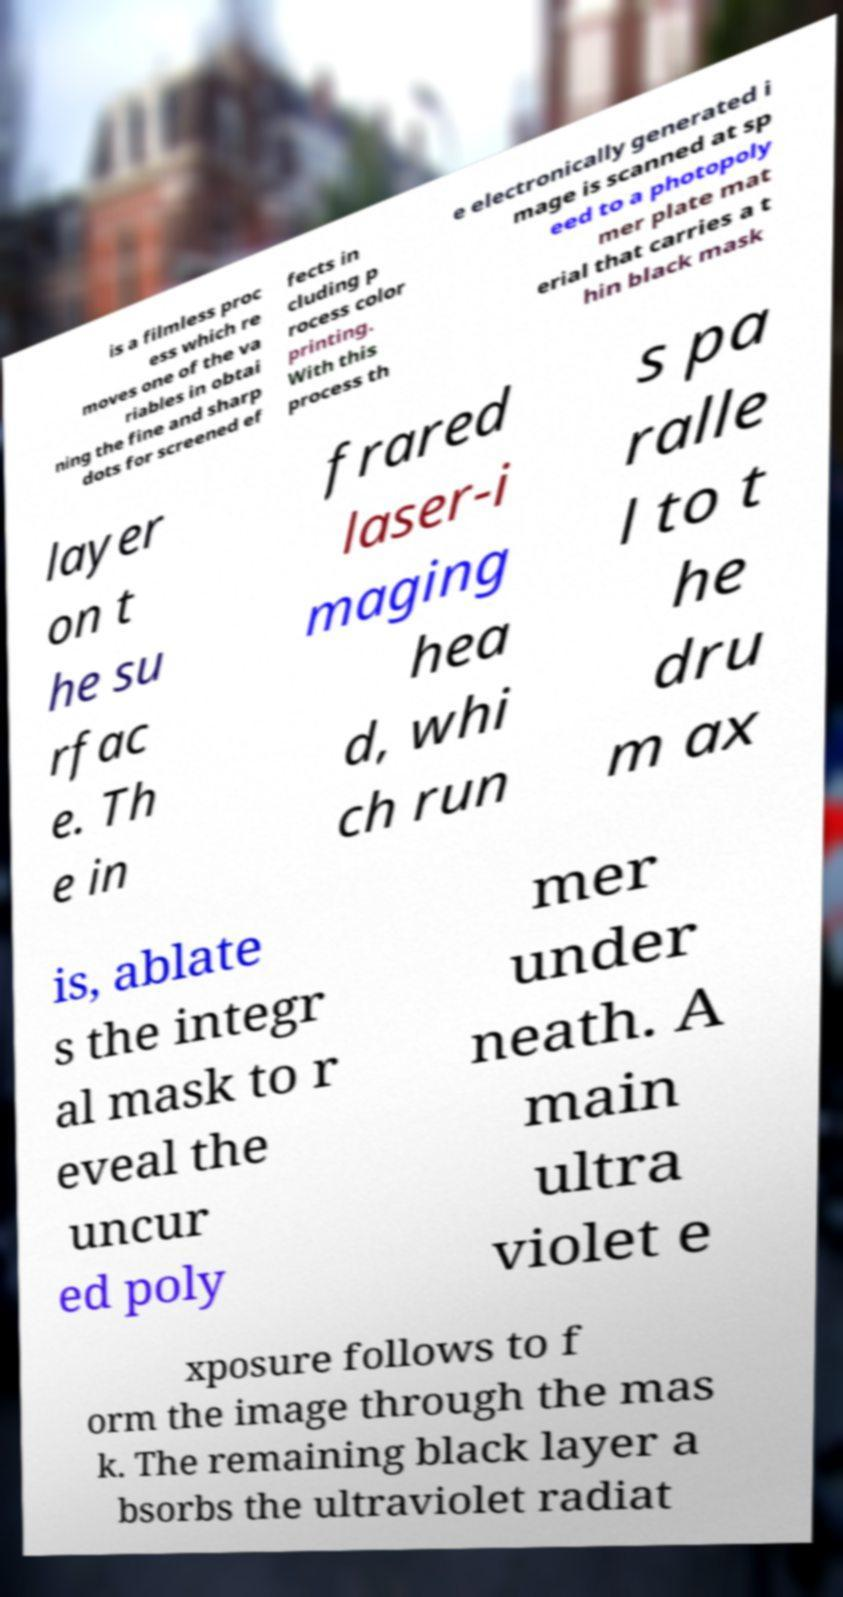I need the written content from this picture converted into text. Can you do that? is a filmless proc ess which re moves one of the va riables in obtai ning the fine and sharp dots for screened ef fects in cluding p rocess color printing. With this process th e electronically generated i mage is scanned at sp eed to a photopoly mer plate mat erial that carries a t hin black mask layer on t he su rfac e. Th e in frared laser-i maging hea d, whi ch run s pa ralle l to t he dru m ax is, ablate s the integr al mask to r eveal the uncur ed poly mer under neath. A main ultra violet e xposure follows to f orm the image through the mas k. The remaining black layer a bsorbs the ultraviolet radiat 